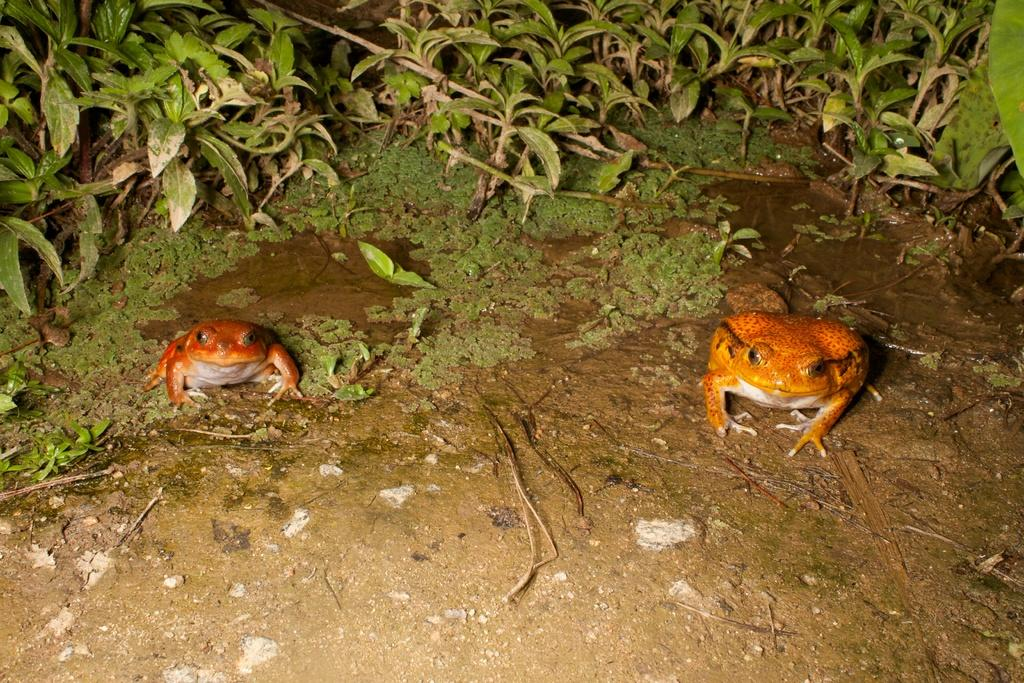How many frogs are in the image? There are two frogs in the image. What is visible in the image besides the frogs? Water, plants, and algae are present in the image. What type of environment might the image depict? The image might depict a natural environment, such as a pond or a marsh, given the presence of water, plants, and algae. What type of connection can be seen between the frogs in the image? There is no visible connection between the frogs in the image. What type of waves can be seen in the image? There are no waves present in the image; it features two frogs in a body of water with plants and algae. 